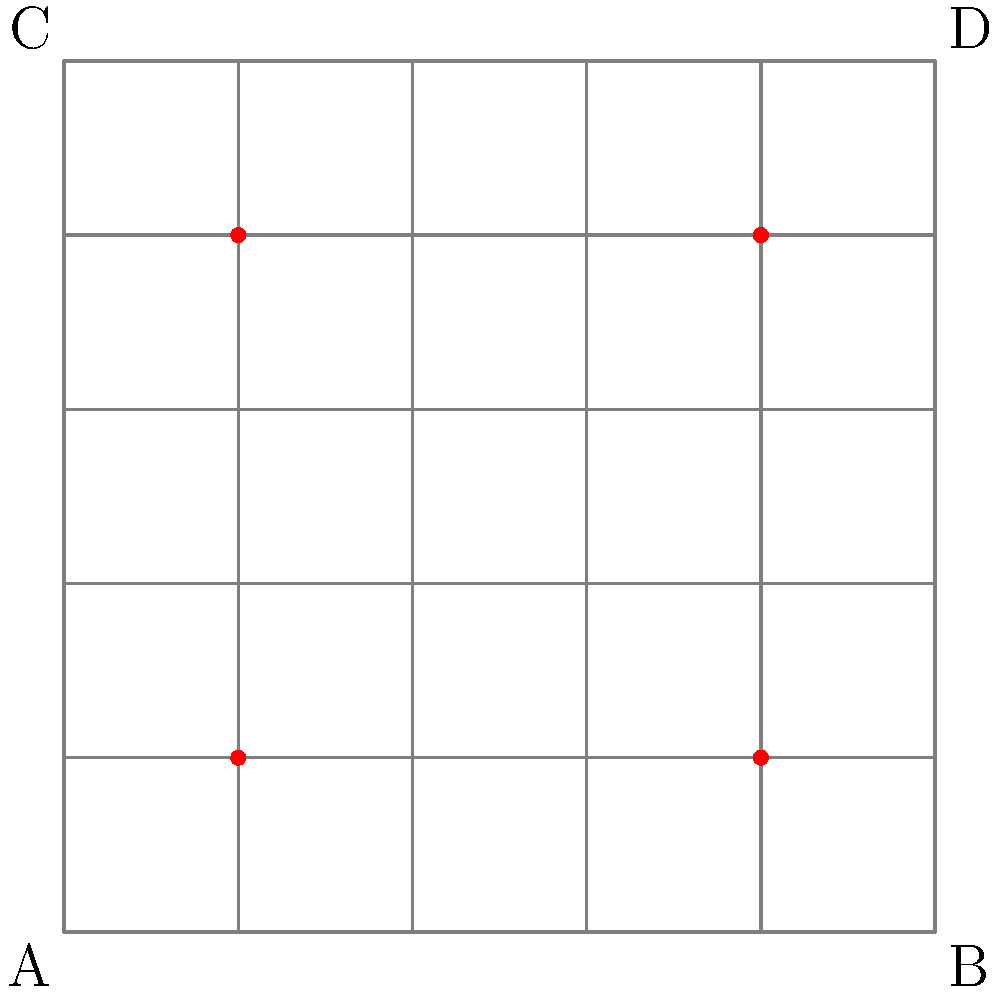Given a 5x5 grid representing a street intersection during a protest, security personnel are placed at coordinates (1,1), (1,4), (4,1), and (4,4) as shown by the red dots. What is the minimum number of additional security personnel needed to ensure that every grid point is either occupied or adjacent (horizontally or vertically) to an occupied point? To solve this problem, we need to follow these steps:

1. Identify the current coverage:
   - Each security personnel covers 5 points (their position plus 4 adjacent points)
   - (1,1) covers: (0,1), (1,0), (1,1), (1,2), (2,1)
   - (1,4) covers: (0,4), (1,3), (1,4), (1,5), (2,4)
   - (4,1) covers: (3,1), (4,0), (4,1), (4,2), (5,1)
   - (4,4) covers: (3,4), (4,3), (4,4), (4,5), (5,4)

2. Identify uncovered points:
   - The center point (2,2) and its adjacent points (2,3) and (3,2) are not covered
   - Point (3,3) is also not covered

3. Determine the minimum additional personnel:
   - Placing one security personnel at (2,2) would cover (1,2), (2,1), (2,2), (2,3), (3,2)
   - This covers all previously uncovered points

Therefore, only one additional security personnel is needed to ensure complete coverage of the grid.
Answer: 1 